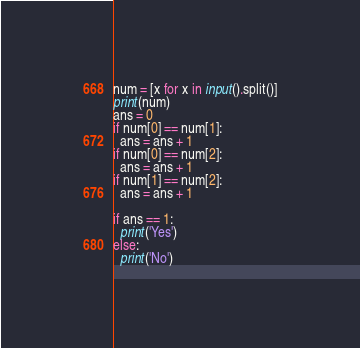Convert code to text. <code><loc_0><loc_0><loc_500><loc_500><_Python_>num = [x for x in input().split()]
print(num)
ans = 0
if num[0] == num[1]:
  ans = ans + 1
if num[0] == num[2]:
  ans = ans + 1
if num[1] == num[2]:
  ans = ans + 1

if ans == 1:
  print('Yes')
else:
  print('No')
</code> 